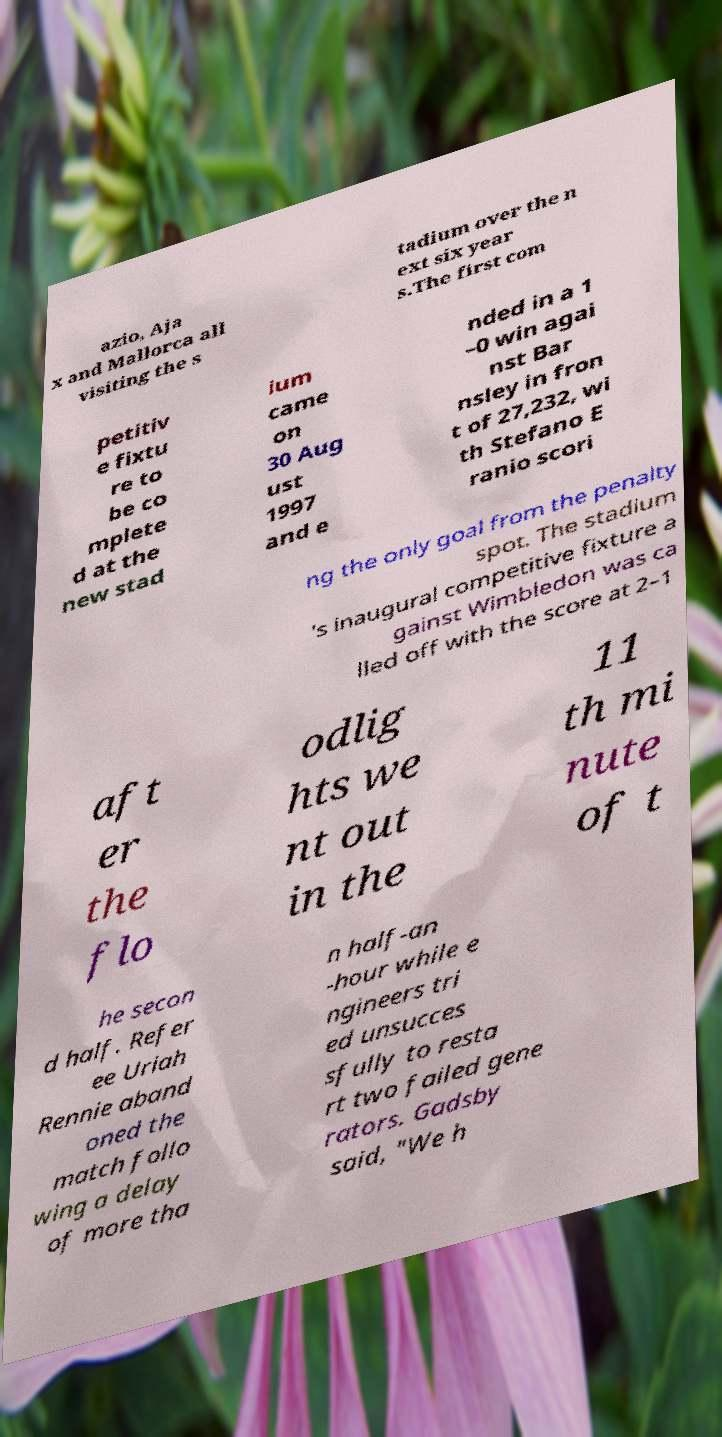Please read and relay the text visible in this image. What does it say? azio, Aja x and Mallorca all visiting the s tadium over the n ext six year s.The first com petitiv e fixtu re to be co mplete d at the new stad ium came on 30 Aug ust 1997 and e nded in a 1 –0 win agai nst Bar nsley in fron t of 27,232, wi th Stefano E ranio scori ng the only goal from the penalty spot. The stadium 's inaugural competitive fixture a gainst Wimbledon was ca lled off with the score at 2–1 aft er the flo odlig hts we nt out in the 11 th mi nute of t he secon d half. Refer ee Uriah Rennie aband oned the match follo wing a delay of more tha n half-an -hour while e ngineers tri ed unsucces sfully to resta rt two failed gene rators. Gadsby said, "We h 